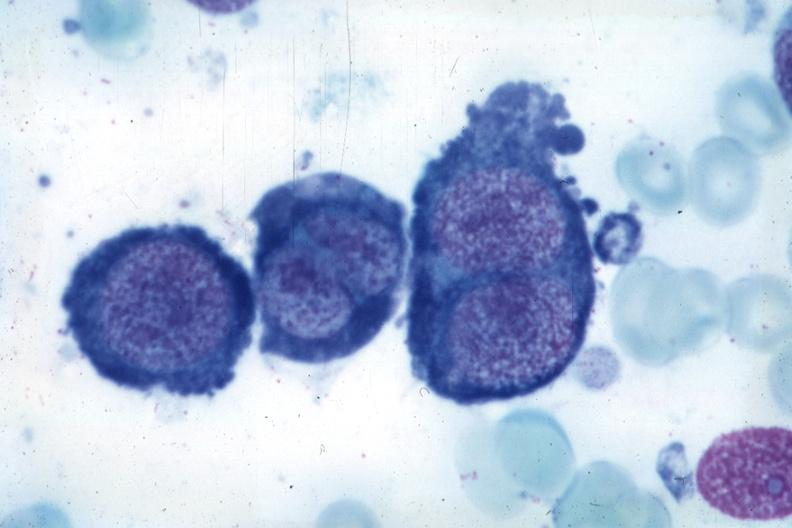what is present?
Answer the question using a single word or phrase. Hematologic 